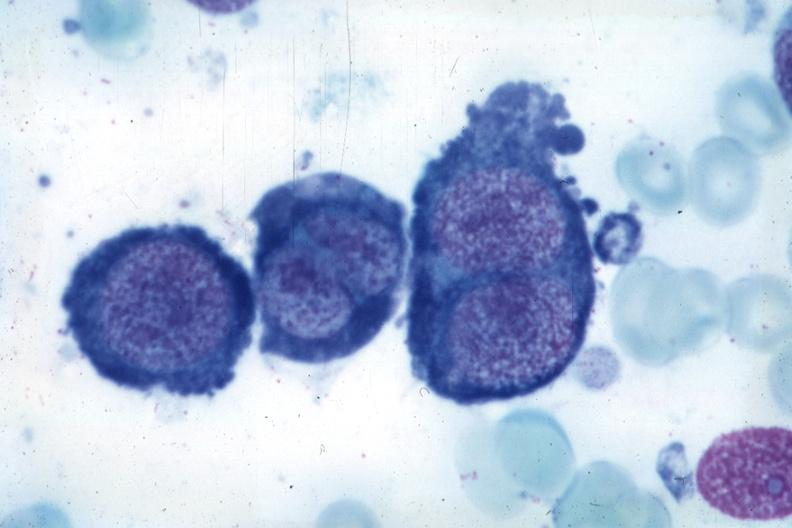what is present?
Answer the question using a single word or phrase. Hematologic 